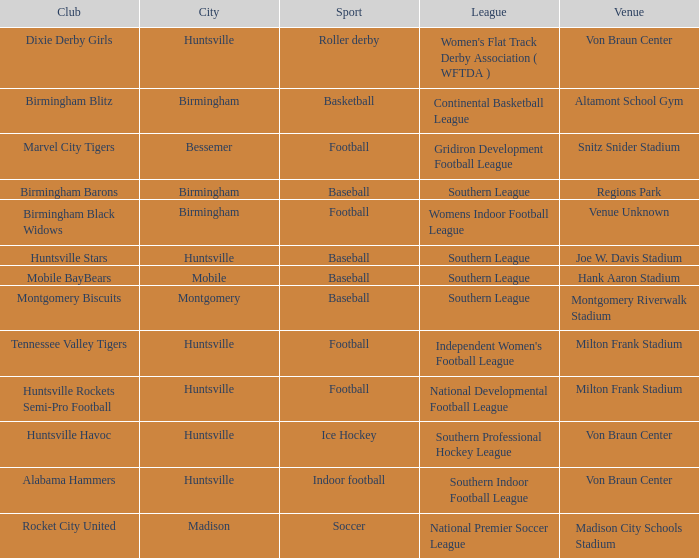Which city has a club called the Huntsville Stars? Huntsville. 